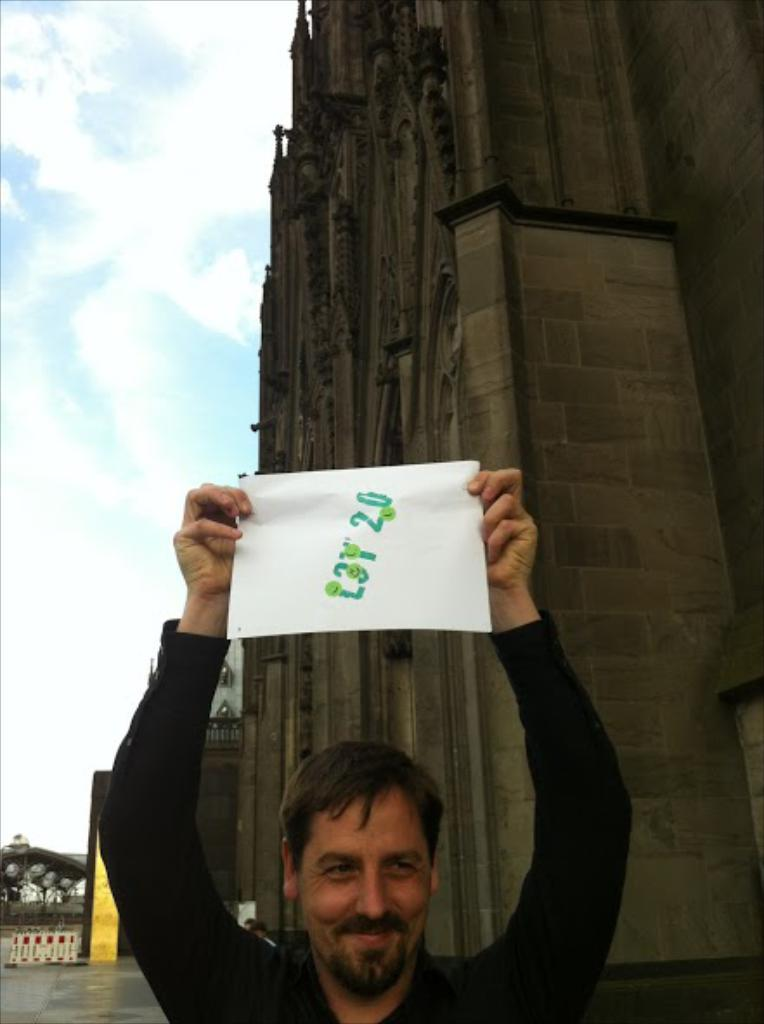Who is in the image? There is a man in the image. What is the man holding in the image? The man is holding paper with both hands. Can you describe the paper in the image? There is text on the paper. What can be seen in the background of the image? There is a huge building with beautiful carvings in the background. What type of wool is being used to create the shape of the man in the image? There is no wool or shape being created in the image; it is a photograph of a man holding paper. 